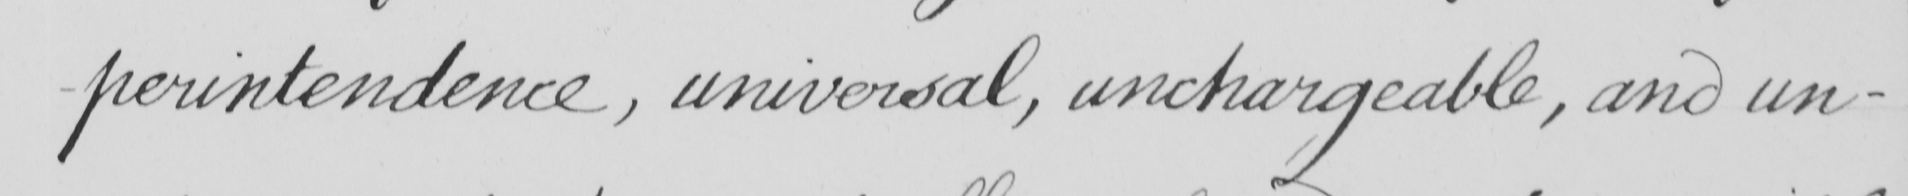Please transcribe the handwritten text in this image. -perintendence , universal , unchargeable , and un- 